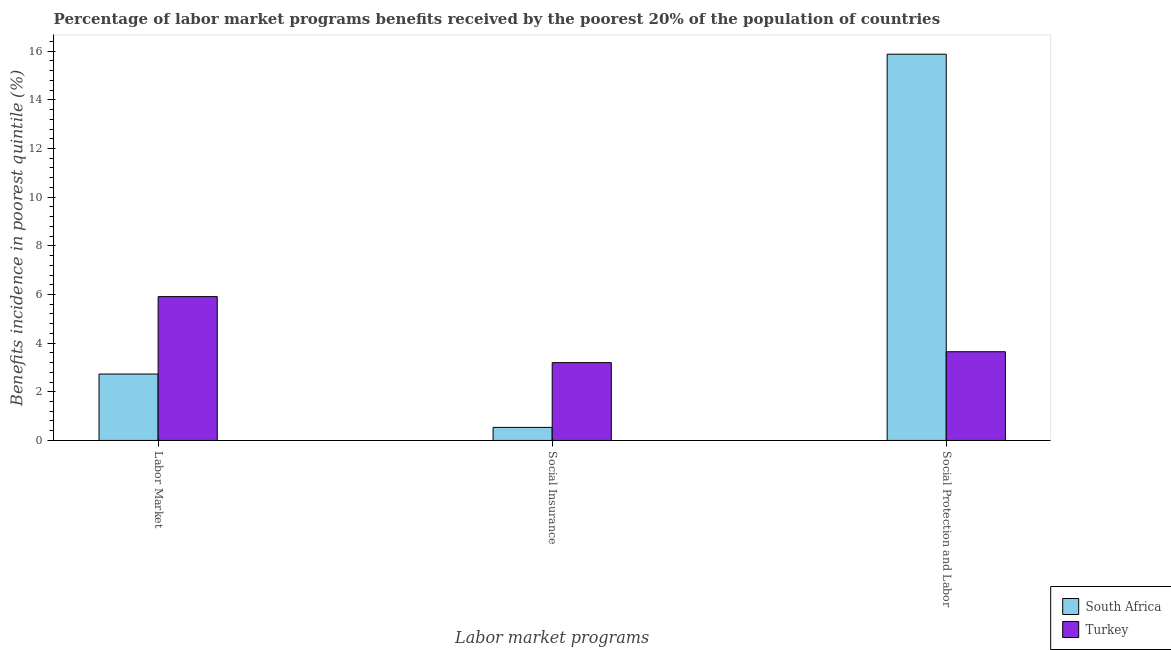Are the number of bars on each tick of the X-axis equal?
Your answer should be compact. Yes. How many bars are there on the 1st tick from the left?
Your answer should be compact. 2. How many bars are there on the 1st tick from the right?
Give a very brief answer. 2. What is the label of the 3rd group of bars from the left?
Your answer should be compact. Social Protection and Labor. What is the percentage of benefits received due to social protection programs in South Africa?
Your answer should be compact. 15.88. Across all countries, what is the maximum percentage of benefits received due to labor market programs?
Give a very brief answer. 5.91. Across all countries, what is the minimum percentage of benefits received due to social insurance programs?
Offer a very short reply. 0.54. In which country was the percentage of benefits received due to social protection programs maximum?
Keep it short and to the point. South Africa. In which country was the percentage of benefits received due to social protection programs minimum?
Keep it short and to the point. Turkey. What is the total percentage of benefits received due to social insurance programs in the graph?
Provide a succinct answer. 3.74. What is the difference between the percentage of benefits received due to social protection programs in Turkey and that in South Africa?
Provide a short and direct response. -12.23. What is the difference between the percentage of benefits received due to social insurance programs in South Africa and the percentage of benefits received due to social protection programs in Turkey?
Ensure brevity in your answer.  -3.11. What is the average percentage of benefits received due to labor market programs per country?
Offer a terse response. 4.32. What is the difference between the percentage of benefits received due to social insurance programs and percentage of benefits received due to social protection programs in Turkey?
Keep it short and to the point. -0.45. What is the ratio of the percentage of benefits received due to social protection programs in South Africa to that in Turkey?
Make the answer very short. 4.35. Is the percentage of benefits received due to social insurance programs in South Africa less than that in Turkey?
Keep it short and to the point. Yes. Is the difference between the percentage of benefits received due to labor market programs in South Africa and Turkey greater than the difference between the percentage of benefits received due to social protection programs in South Africa and Turkey?
Offer a terse response. No. What is the difference between the highest and the second highest percentage of benefits received due to social protection programs?
Give a very brief answer. 12.23. What is the difference between the highest and the lowest percentage of benefits received due to labor market programs?
Give a very brief answer. 3.18. What does the 1st bar from the left in Social Protection and Labor represents?
Offer a very short reply. South Africa. What does the 2nd bar from the right in Labor Market represents?
Give a very brief answer. South Africa. Is it the case that in every country, the sum of the percentage of benefits received due to labor market programs and percentage of benefits received due to social insurance programs is greater than the percentage of benefits received due to social protection programs?
Provide a short and direct response. No. How many bars are there?
Keep it short and to the point. 6. Are all the bars in the graph horizontal?
Offer a very short reply. No. What is the difference between two consecutive major ticks on the Y-axis?
Provide a succinct answer. 2. Are the values on the major ticks of Y-axis written in scientific E-notation?
Ensure brevity in your answer.  No. Where does the legend appear in the graph?
Offer a terse response. Bottom right. What is the title of the graph?
Ensure brevity in your answer.  Percentage of labor market programs benefits received by the poorest 20% of the population of countries. What is the label or title of the X-axis?
Your answer should be compact. Labor market programs. What is the label or title of the Y-axis?
Provide a short and direct response. Benefits incidence in poorest quintile (%). What is the Benefits incidence in poorest quintile (%) in South Africa in Labor Market?
Offer a very short reply. 2.73. What is the Benefits incidence in poorest quintile (%) of Turkey in Labor Market?
Your answer should be very brief. 5.91. What is the Benefits incidence in poorest quintile (%) in South Africa in Social Insurance?
Give a very brief answer. 0.54. What is the Benefits incidence in poorest quintile (%) in Turkey in Social Insurance?
Offer a terse response. 3.2. What is the Benefits incidence in poorest quintile (%) of South Africa in Social Protection and Labor?
Your answer should be very brief. 15.88. What is the Benefits incidence in poorest quintile (%) in Turkey in Social Protection and Labor?
Provide a succinct answer. 3.65. Across all Labor market programs, what is the maximum Benefits incidence in poorest quintile (%) of South Africa?
Your answer should be compact. 15.88. Across all Labor market programs, what is the maximum Benefits incidence in poorest quintile (%) in Turkey?
Keep it short and to the point. 5.91. Across all Labor market programs, what is the minimum Benefits incidence in poorest quintile (%) of South Africa?
Keep it short and to the point. 0.54. Across all Labor market programs, what is the minimum Benefits incidence in poorest quintile (%) of Turkey?
Offer a very short reply. 3.2. What is the total Benefits incidence in poorest quintile (%) in South Africa in the graph?
Ensure brevity in your answer.  19.14. What is the total Benefits incidence in poorest quintile (%) in Turkey in the graph?
Offer a very short reply. 12.76. What is the difference between the Benefits incidence in poorest quintile (%) of South Africa in Labor Market and that in Social Insurance?
Ensure brevity in your answer.  2.19. What is the difference between the Benefits incidence in poorest quintile (%) of Turkey in Labor Market and that in Social Insurance?
Give a very brief answer. 2.71. What is the difference between the Benefits incidence in poorest quintile (%) in South Africa in Labor Market and that in Social Protection and Labor?
Your response must be concise. -13.15. What is the difference between the Benefits incidence in poorest quintile (%) in Turkey in Labor Market and that in Social Protection and Labor?
Offer a terse response. 2.27. What is the difference between the Benefits incidence in poorest quintile (%) in South Africa in Social Insurance and that in Social Protection and Labor?
Provide a succinct answer. -15.34. What is the difference between the Benefits incidence in poorest quintile (%) of Turkey in Social Insurance and that in Social Protection and Labor?
Your response must be concise. -0.45. What is the difference between the Benefits incidence in poorest quintile (%) of South Africa in Labor Market and the Benefits incidence in poorest quintile (%) of Turkey in Social Insurance?
Make the answer very short. -0.47. What is the difference between the Benefits incidence in poorest quintile (%) of South Africa in Labor Market and the Benefits incidence in poorest quintile (%) of Turkey in Social Protection and Labor?
Your response must be concise. -0.92. What is the difference between the Benefits incidence in poorest quintile (%) in South Africa in Social Insurance and the Benefits incidence in poorest quintile (%) in Turkey in Social Protection and Labor?
Offer a terse response. -3.11. What is the average Benefits incidence in poorest quintile (%) in South Africa per Labor market programs?
Make the answer very short. 6.38. What is the average Benefits incidence in poorest quintile (%) of Turkey per Labor market programs?
Your response must be concise. 4.25. What is the difference between the Benefits incidence in poorest quintile (%) of South Africa and Benefits incidence in poorest quintile (%) of Turkey in Labor Market?
Provide a succinct answer. -3.18. What is the difference between the Benefits incidence in poorest quintile (%) in South Africa and Benefits incidence in poorest quintile (%) in Turkey in Social Insurance?
Offer a terse response. -2.66. What is the difference between the Benefits incidence in poorest quintile (%) of South Africa and Benefits incidence in poorest quintile (%) of Turkey in Social Protection and Labor?
Ensure brevity in your answer.  12.23. What is the ratio of the Benefits incidence in poorest quintile (%) of South Africa in Labor Market to that in Social Insurance?
Your response must be concise. 5.09. What is the ratio of the Benefits incidence in poorest quintile (%) of Turkey in Labor Market to that in Social Insurance?
Make the answer very short. 1.85. What is the ratio of the Benefits incidence in poorest quintile (%) in South Africa in Labor Market to that in Social Protection and Labor?
Provide a short and direct response. 0.17. What is the ratio of the Benefits incidence in poorest quintile (%) of Turkey in Labor Market to that in Social Protection and Labor?
Your answer should be very brief. 1.62. What is the ratio of the Benefits incidence in poorest quintile (%) of South Africa in Social Insurance to that in Social Protection and Labor?
Offer a terse response. 0.03. What is the ratio of the Benefits incidence in poorest quintile (%) in Turkey in Social Insurance to that in Social Protection and Labor?
Offer a very short reply. 0.88. What is the difference between the highest and the second highest Benefits incidence in poorest quintile (%) in South Africa?
Offer a terse response. 13.15. What is the difference between the highest and the second highest Benefits incidence in poorest quintile (%) of Turkey?
Offer a very short reply. 2.27. What is the difference between the highest and the lowest Benefits incidence in poorest quintile (%) in South Africa?
Keep it short and to the point. 15.34. What is the difference between the highest and the lowest Benefits incidence in poorest quintile (%) of Turkey?
Provide a succinct answer. 2.71. 